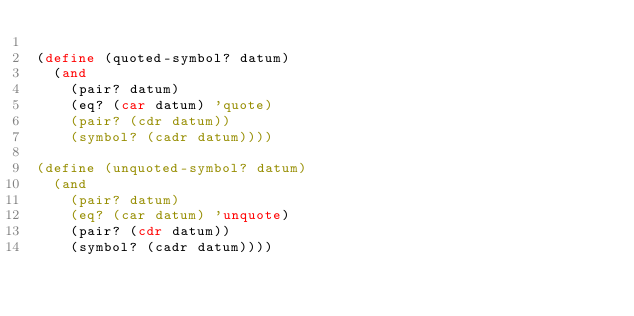<code> <loc_0><loc_0><loc_500><loc_500><_Scheme_>
(define (quoted-symbol? datum)
  (and
    (pair? datum)
    (eq? (car datum) 'quote)
    (pair? (cdr datum))
    (symbol? (cadr datum))))

(define (unquoted-symbol? datum)
  (and
    (pair? datum)
    (eq? (car datum) 'unquote)
    (pair? (cdr datum))
    (symbol? (cadr datum))))

</code> 